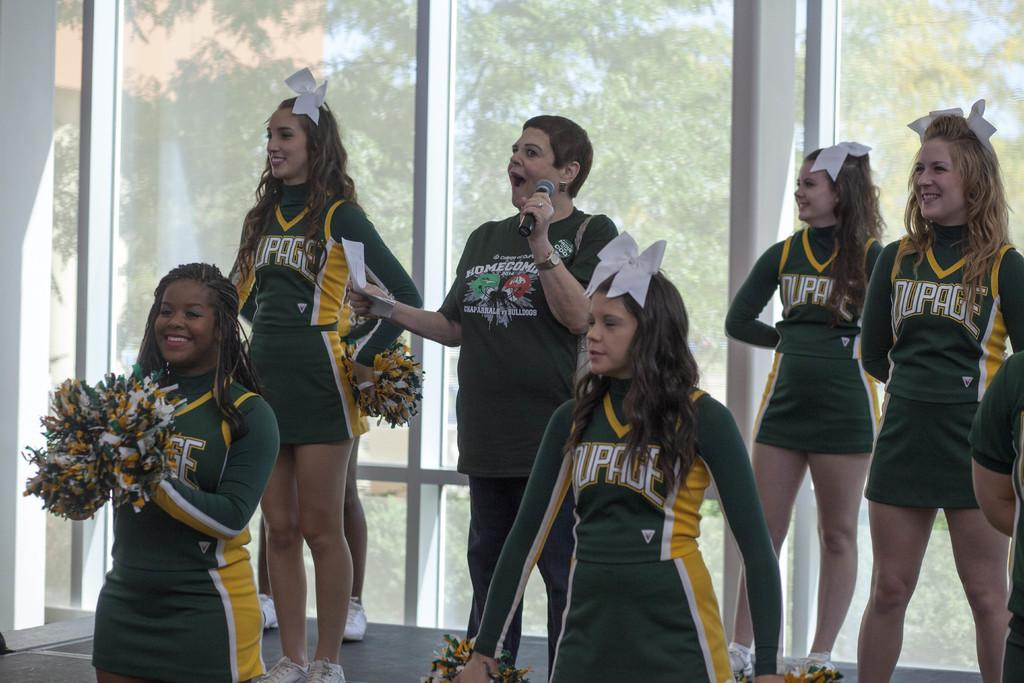<image>
Present a compact description of the photo's key features. the word Dupage that is on a green jersey 